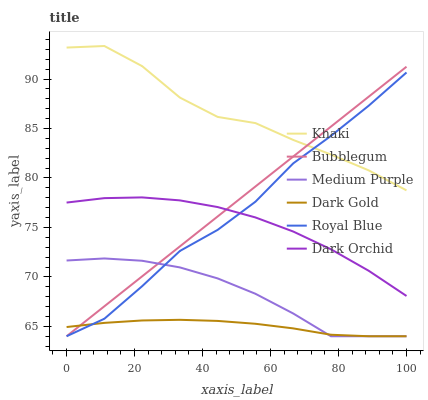Does Dark Gold have the minimum area under the curve?
Answer yes or no. Yes. Does Khaki have the maximum area under the curve?
Answer yes or no. Yes. Does Dark Orchid have the minimum area under the curve?
Answer yes or no. No. Does Dark Orchid have the maximum area under the curve?
Answer yes or no. No. Is Bubblegum the smoothest?
Answer yes or no. Yes. Is Khaki the roughest?
Answer yes or no. Yes. Is Dark Gold the smoothest?
Answer yes or no. No. Is Dark Gold the roughest?
Answer yes or no. No. Does Dark Gold have the lowest value?
Answer yes or no. Yes. Does Dark Orchid have the lowest value?
Answer yes or no. No. Does Khaki have the highest value?
Answer yes or no. Yes. Does Dark Orchid have the highest value?
Answer yes or no. No. Is Dark Gold less than Dark Orchid?
Answer yes or no. Yes. Is Khaki greater than Dark Orchid?
Answer yes or no. Yes. Does Bubblegum intersect Royal Blue?
Answer yes or no. Yes. Is Bubblegum less than Royal Blue?
Answer yes or no. No. Is Bubblegum greater than Royal Blue?
Answer yes or no. No. Does Dark Gold intersect Dark Orchid?
Answer yes or no. No. 